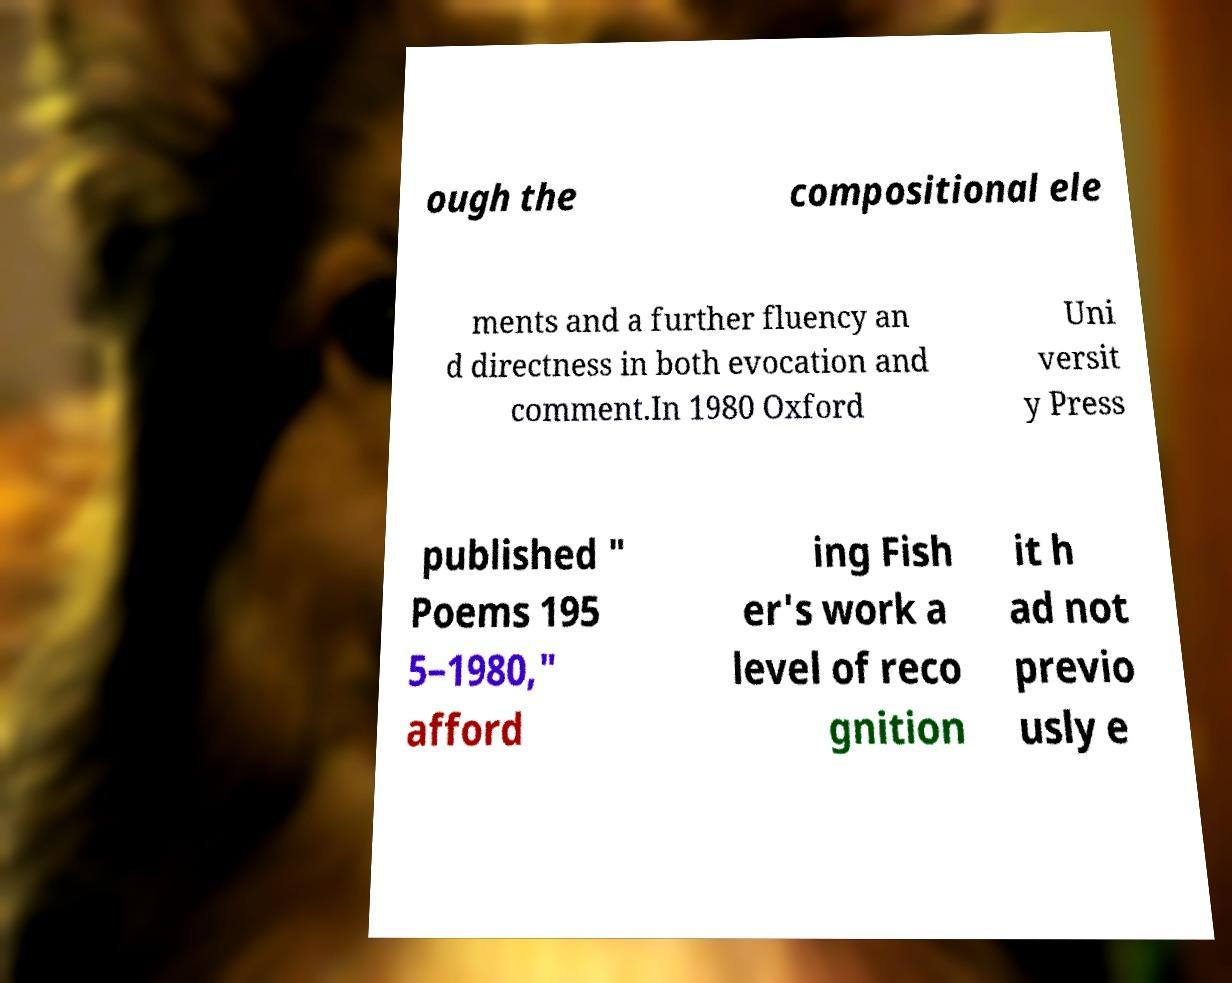Can you accurately transcribe the text from the provided image for me? ough the compositional ele ments and a further fluency an d directness in both evocation and comment.In 1980 Oxford Uni versit y Press published " Poems 195 5–1980," afford ing Fish er's work a level of reco gnition it h ad not previo usly e 